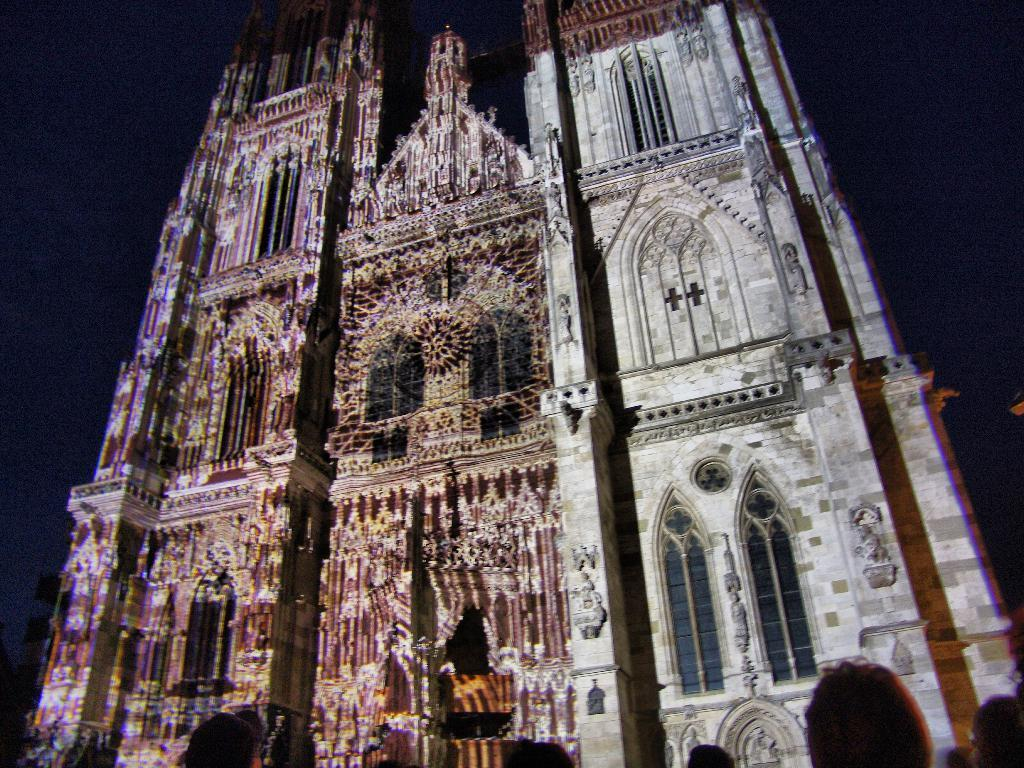What type of building is depicted in the image? There is a building of a cathedral in the image. Are there any additional features associated with the cathedral building? Yes, there are lights associated with the cathedral building. What is the price of the slave depicted in the image? There is no slave present in the image, so it is not possible to determine a price. 